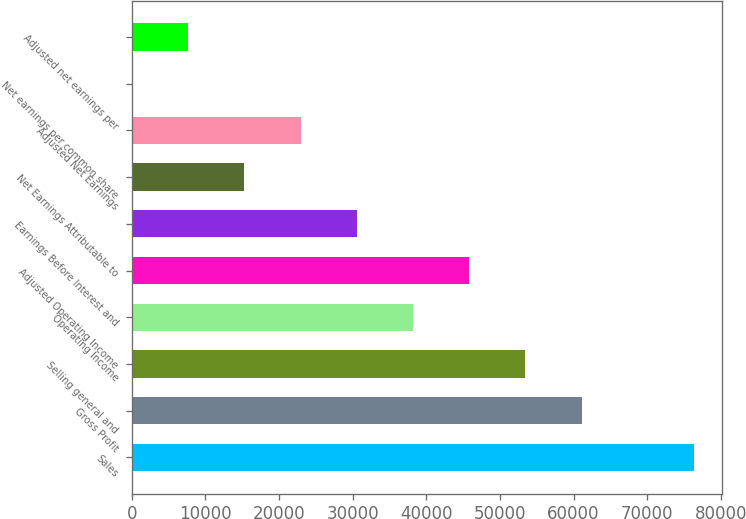Convert chart to OTSL. <chart><loc_0><loc_0><loc_500><loc_500><bar_chart><fcel>Sales<fcel>Gross Profit<fcel>Selling general and<fcel>Operating Income<fcel>Adjusted Operating Income<fcel>Earnings Before Interest and<fcel>Net Earnings Attributable to<fcel>Adjusted Net Earnings<fcel>Net earnings per common share<fcel>Adjusted net earnings per<nl><fcel>76392<fcel>61114<fcel>53475<fcel>38197<fcel>45836<fcel>30558<fcel>15280<fcel>22919<fcel>2<fcel>7641<nl></chart> 